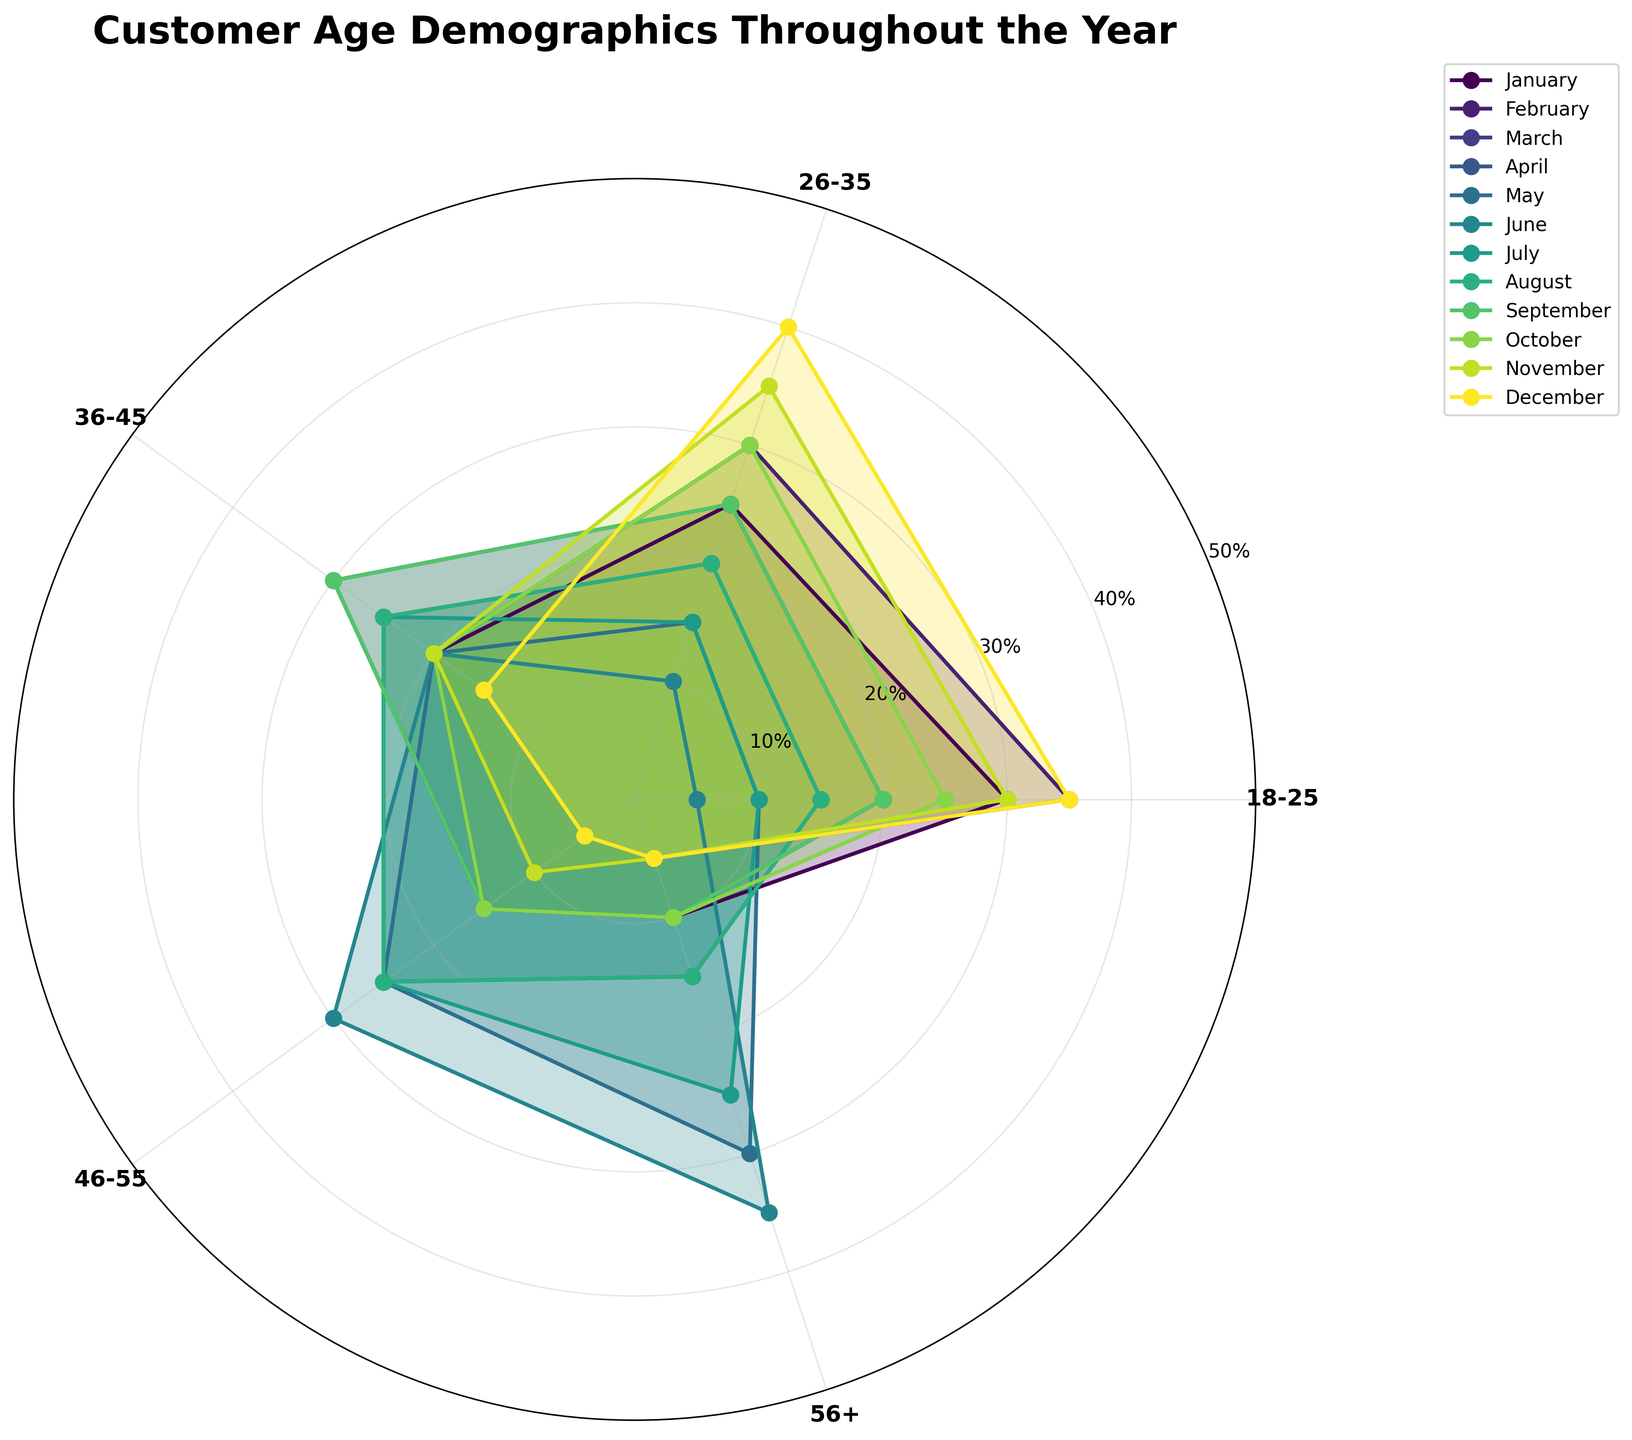Which month has the highest percentage of customers aged 18-25? Scan the figure for the line representing 18-25 age group to find the peak point, which corresponds to February.
Answer: February What is the total percentage of customers aged 26-35 in July and August? Find the values for 26-35 age group in July and August respectively (15% and 20%). Add these values together: 15 + 20 = 35.
Answer: 35% How do the percentages of customers aged 46-55 compare between March and June? Observe the chart to locate the percentages of 46-55 age group for March (15%) and June (30%). Compare: 30% in June is higher than 15% in March.
Answer: Higher in June What is the average percentage of customers aged 56+ during the winter months (December, January, February)? Identify the values for December (5%), January (10%), and February (5%). Sum them: 5 + 10 + 5 = 20. Divide by 3 to get the average: 20 / 3 ≈ 6.67.
Answer: 6.67% In which month do customers aged 36-45 make up the highest percentage? Look for the peak value in the 36-45 age group on the chart, which is March (30%).
Answer: March How does the distribution of customers aged 26-35 change from January to December? Track and compare the values throughout the year: gradual increase peaking at December (January: 25%, December: 40%).
Answer: Increases What's the range of percentages for the 18-25 age group throughout the year? Identify the highest (40% in December) and lowest values (5% in June). Subtract the lowest from the highest: 40 - 5 = 35.
Answer: 35 Which age group shows the most significant change in customer percentage from May to June? Note the shifts in each age group from May to June. The 56+ group increases by 35 - 30 = 5%.
Answer: 56+ What is the percentage of customers aged 36-45 in April? Look at the April data point for the 36-45 age group.
Answer: 25% Which age group maintains an almost constant percentage in the summer months (June, July, August)? Check for the group with little variation in values across June, July, and August. The 36-45 group has 20%, 25%, and 25% respectively.
Answer: 36-45 